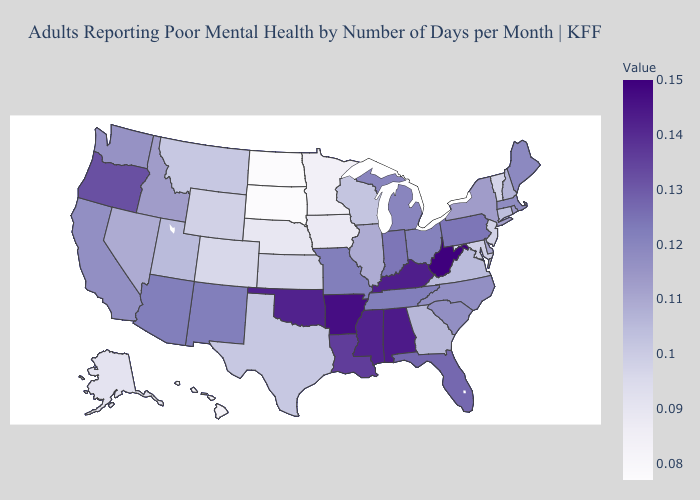Does Washington have a higher value than Arkansas?
Be succinct. No. Does the map have missing data?
Quick response, please. No. Does South Dakota have the lowest value in the MidWest?
Short answer required. Yes. Which states have the lowest value in the USA?
Quick response, please. North Dakota, South Dakota. Is the legend a continuous bar?
Keep it brief. Yes. Does Massachusetts have a higher value than South Dakota?
Give a very brief answer. Yes. 